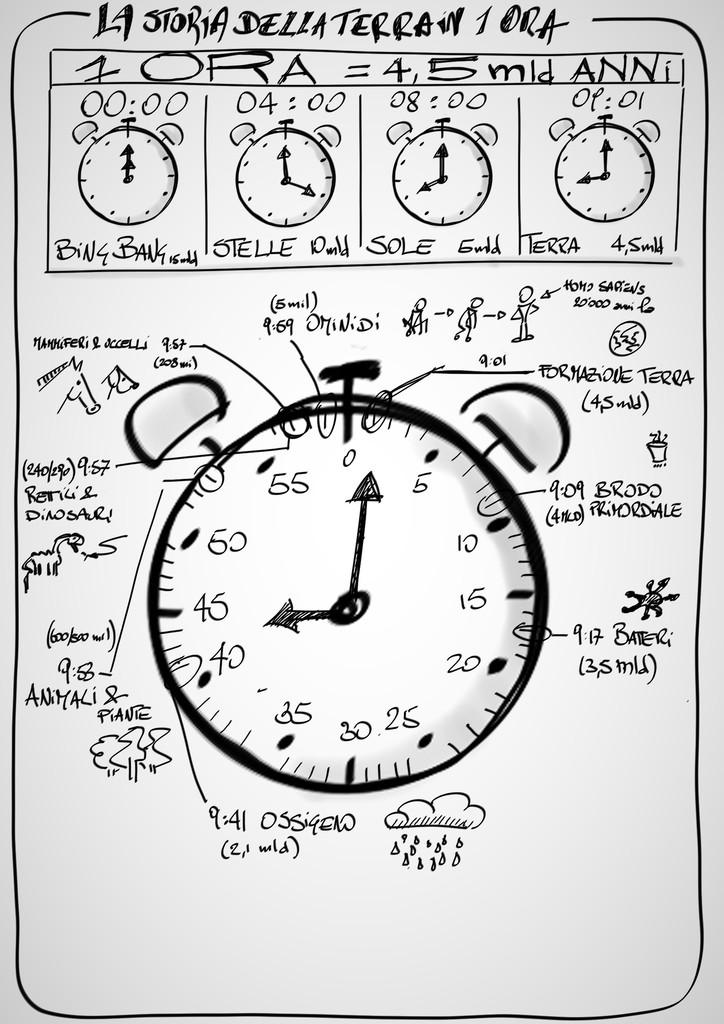<image>
Relay a brief, clear account of the picture shown. A drawing that reads LA STORIA DELLA TERRAN 1 ORA. 